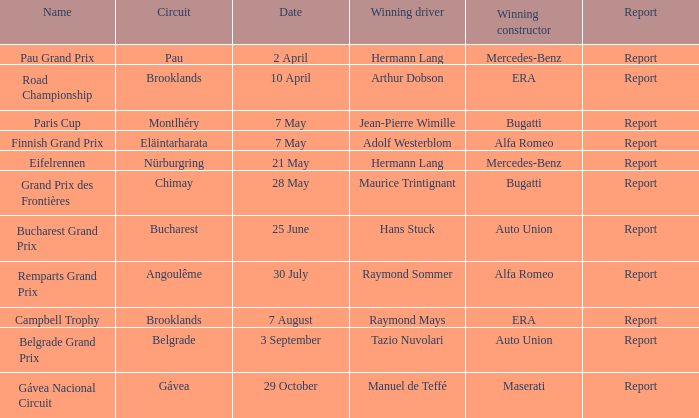Tell me the winning driver for pau grand prix Hermann Lang. 